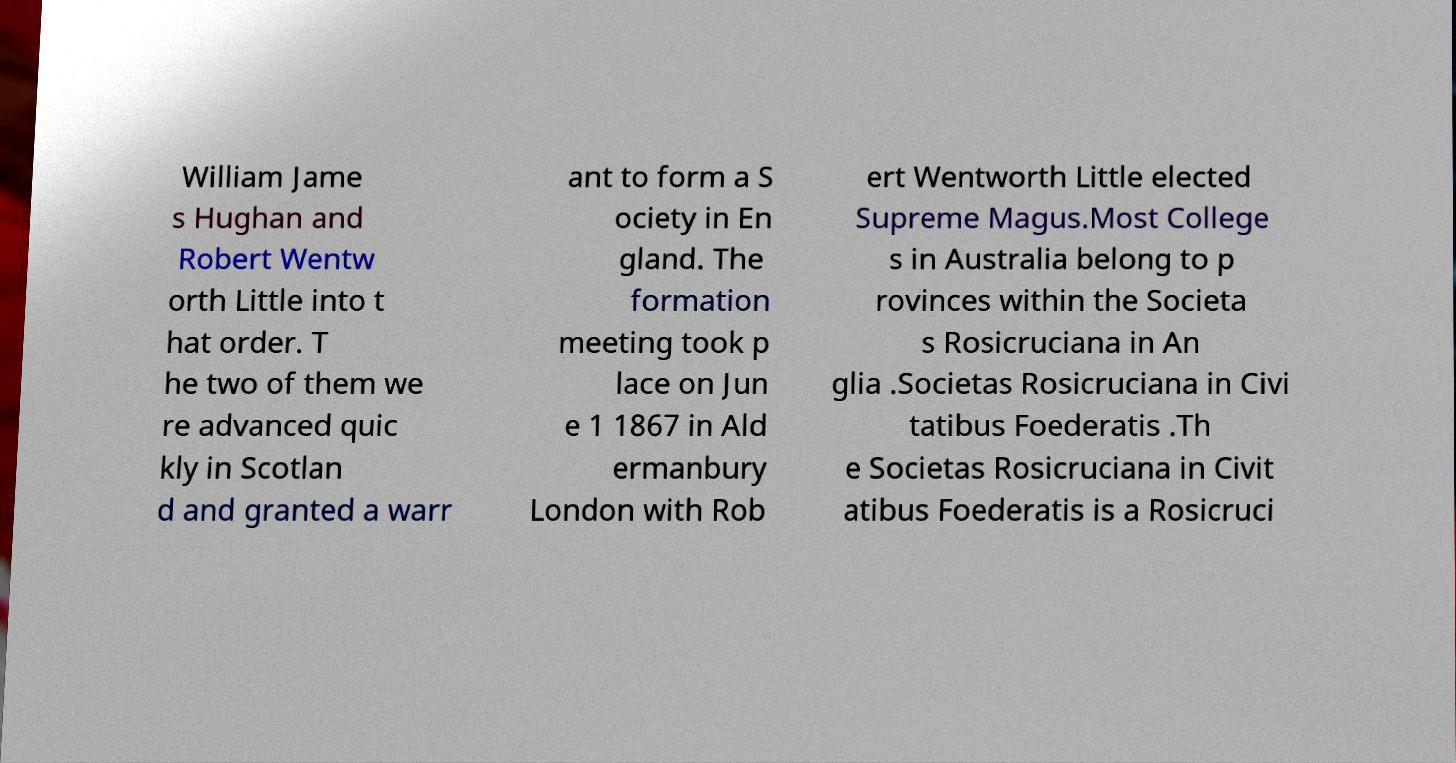I need the written content from this picture converted into text. Can you do that? William Jame s Hughan and Robert Wentw orth Little into t hat order. T he two of them we re advanced quic kly in Scotlan d and granted a warr ant to form a S ociety in En gland. The formation meeting took p lace on Jun e 1 1867 in Ald ermanbury London with Rob ert Wentworth Little elected Supreme Magus.Most College s in Australia belong to p rovinces within the Societa s Rosicruciana in An glia .Societas Rosicruciana in Civi tatibus Foederatis .Th e Societas Rosicruciana in Civit atibus Foederatis is a Rosicruci 